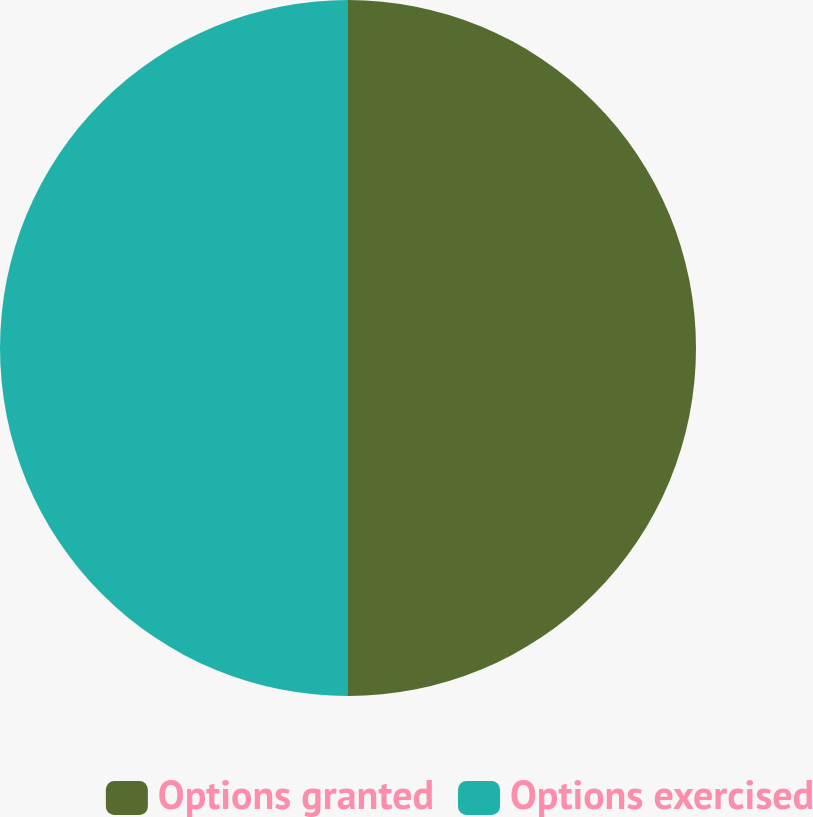Convert chart to OTSL. <chart><loc_0><loc_0><loc_500><loc_500><pie_chart><fcel>Options granted<fcel>Options exercised<nl><fcel>50.0%<fcel>50.0%<nl></chart> 